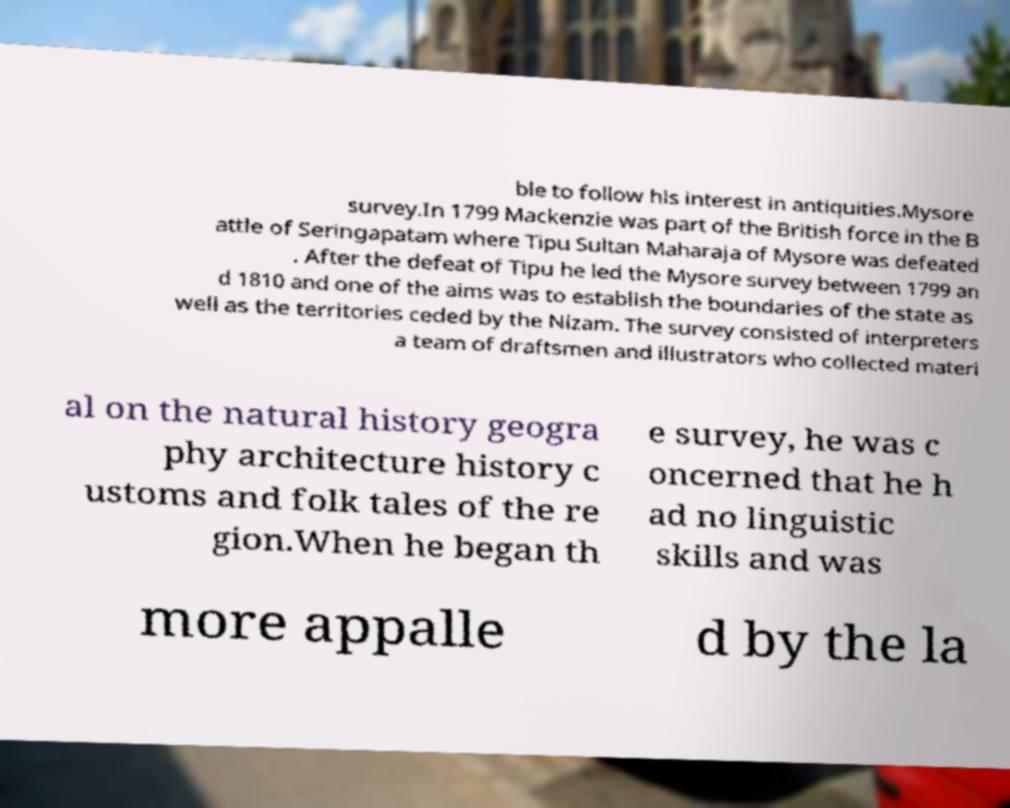Please read and relay the text visible in this image. What does it say? ble to follow his interest in antiquities.Mysore survey.In 1799 Mackenzie was part of the British force in the B attle of Seringapatam where Tipu Sultan Maharaja of Mysore was defeated . After the defeat of Tipu he led the Mysore survey between 1799 an d 1810 and one of the aims was to establish the boundaries of the state as well as the territories ceded by the Nizam. The survey consisted of interpreters a team of draftsmen and illustrators who collected materi al on the natural history geogra phy architecture history c ustoms and folk tales of the re gion.When he began th e survey, he was c oncerned that he h ad no linguistic skills and was more appalle d by the la 